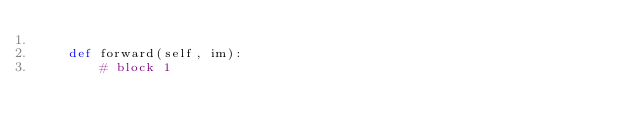<code> <loc_0><loc_0><loc_500><loc_500><_Python_>    
    def forward(self, im):
        # block 1</code> 